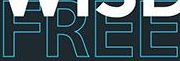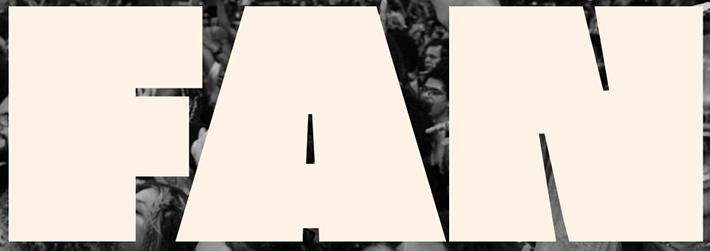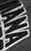Transcribe the words shown in these images in order, separated by a semicolon. FREE; FAN; IANA 